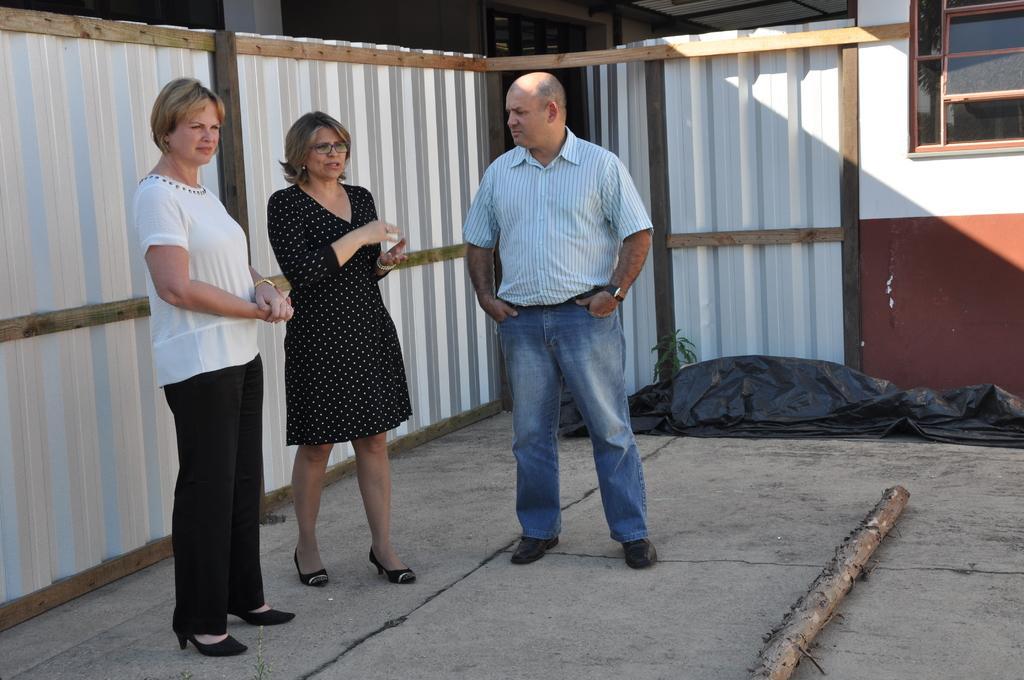In one or two sentences, can you explain what this image depicts? In this picture I can see few people standing and I can see building and I can see a cover and a wooden pole on the ground. 